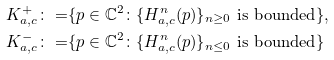<formula> <loc_0><loc_0><loc_500><loc_500>K _ { a , c } ^ { + } \colon = & \{ p \in \mathbb { C } ^ { 2 } \colon \{ H _ { a , c } ^ { n } ( p ) \} _ { n \geq 0 } \text { is bounded} \} , \\ K _ { a , c } ^ { - } \colon = & \{ p \in \mathbb { C } ^ { 2 } \colon \{ H _ { a , c } ^ { n } ( p ) \} _ { n \leq 0 } \text { is bounded} \}</formula> 